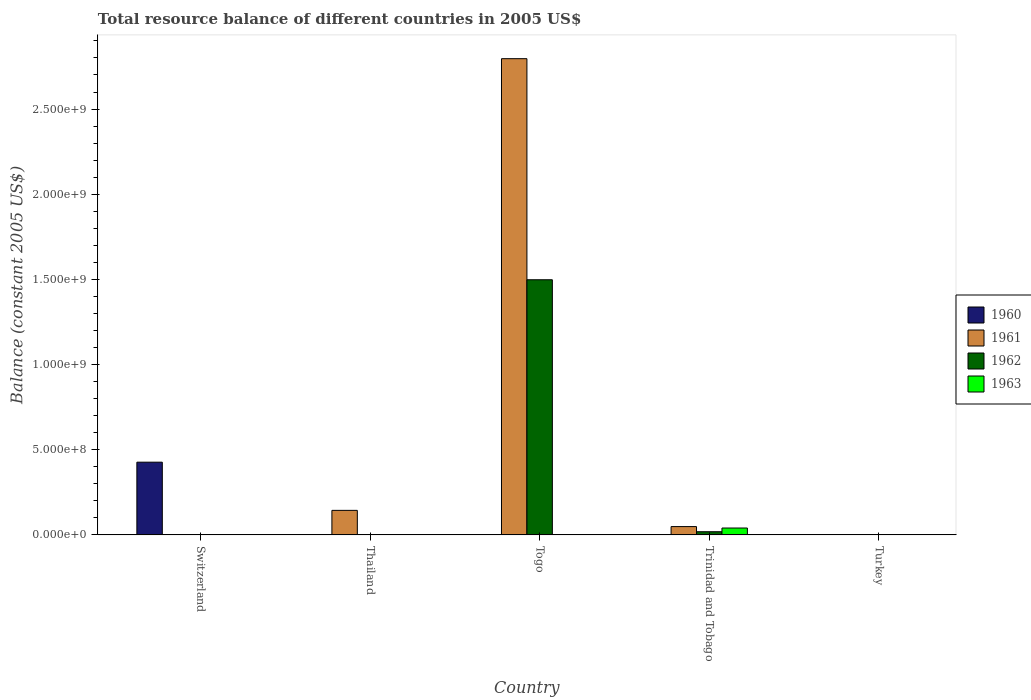Are the number of bars per tick equal to the number of legend labels?
Offer a very short reply. No. What is the label of the 3rd group of bars from the left?
Provide a succinct answer. Togo. What is the total resource balance in 1962 in Turkey?
Offer a terse response. 0. Across all countries, what is the maximum total resource balance in 1960?
Provide a short and direct response. 4.27e+08. Across all countries, what is the minimum total resource balance in 1960?
Make the answer very short. 0. In which country was the total resource balance in 1962 maximum?
Provide a succinct answer. Togo. What is the total total resource balance in 1962 in the graph?
Offer a very short reply. 1.52e+09. What is the difference between the total resource balance in 1961 in Thailand and that in Togo?
Offer a very short reply. -2.65e+09. What is the average total resource balance in 1961 per country?
Offer a very short reply. 5.98e+08. What is the difference between the total resource balance of/in 1962 and total resource balance of/in 1963 in Trinidad and Tobago?
Your answer should be compact. -2.17e+07. What is the ratio of the total resource balance in 1962 in Togo to that in Trinidad and Tobago?
Offer a terse response. 80.54. What is the difference between the highest and the second highest total resource balance in 1961?
Offer a terse response. 9.52e+07. What is the difference between the highest and the lowest total resource balance in 1962?
Offer a terse response. 1.50e+09. Is it the case that in every country, the sum of the total resource balance in 1962 and total resource balance in 1961 is greater than the sum of total resource balance in 1963 and total resource balance in 1960?
Ensure brevity in your answer.  No. Is it the case that in every country, the sum of the total resource balance in 1962 and total resource balance in 1961 is greater than the total resource balance in 1960?
Make the answer very short. No. How many bars are there?
Your answer should be compact. 7. Are all the bars in the graph horizontal?
Make the answer very short. No. How many countries are there in the graph?
Keep it short and to the point. 5. What is the difference between two consecutive major ticks on the Y-axis?
Offer a terse response. 5.00e+08. Does the graph contain any zero values?
Your response must be concise. Yes. Does the graph contain grids?
Offer a very short reply. No. Where does the legend appear in the graph?
Your answer should be compact. Center right. How many legend labels are there?
Keep it short and to the point. 4. What is the title of the graph?
Keep it short and to the point. Total resource balance of different countries in 2005 US$. Does "2011" appear as one of the legend labels in the graph?
Make the answer very short. No. What is the label or title of the Y-axis?
Ensure brevity in your answer.  Balance (constant 2005 US$). What is the Balance (constant 2005 US$) in 1960 in Switzerland?
Give a very brief answer. 4.27e+08. What is the Balance (constant 2005 US$) of 1962 in Switzerland?
Offer a very short reply. 0. What is the Balance (constant 2005 US$) in 1960 in Thailand?
Provide a succinct answer. 0. What is the Balance (constant 2005 US$) of 1961 in Thailand?
Provide a short and direct response. 1.44e+08. What is the Balance (constant 2005 US$) of 1960 in Togo?
Keep it short and to the point. 0. What is the Balance (constant 2005 US$) in 1961 in Togo?
Offer a terse response. 2.80e+09. What is the Balance (constant 2005 US$) in 1962 in Togo?
Offer a terse response. 1.50e+09. What is the Balance (constant 2005 US$) of 1960 in Trinidad and Tobago?
Provide a succinct answer. 0. What is the Balance (constant 2005 US$) in 1961 in Trinidad and Tobago?
Your answer should be very brief. 4.88e+07. What is the Balance (constant 2005 US$) of 1962 in Trinidad and Tobago?
Offer a terse response. 1.86e+07. What is the Balance (constant 2005 US$) in 1963 in Trinidad and Tobago?
Your response must be concise. 4.03e+07. What is the Balance (constant 2005 US$) in 1960 in Turkey?
Ensure brevity in your answer.  0. What is the Balance (constant 2005 US$) of 1961 in Turkey?
Your response must be concise. 0. What is the Balance (constant 2005 US$) of 1962 in Turkey?
Offer a very short reply. 0. Across all countries, what is the maximum Balance (constant 2005 US$) of 1960?
Provide a succinct answer. 4.27e+08. Across all countries, what is the maximum Balance (constant 2005 US$) of 1961?
Your response must be concise. 2.80e+09. Across all countries, what is the maximum Balance (constant 2005 US$) in 1962?
Your answer should be compact. 1.50e+09. Across all countries, what is the maximum Balance (constant 2005 US$) in 1963?
Make the answer very short. 4.03e+07. Across all countries, what is the minimum Balance (constant 2005 US$) in 1960?
Provide a succinct answer. 0. Across all countries, what is the minimum Balance (constant 2005 US$) in 1961?
Ensure brevity in your answer.  0. What is the total Balance (constant 2005 US$) of 1960 in the graph?
Your response must be concise. 4.27e+08. What is the total Balance (constant 2005 US$) of 1961 in the graph?
Give a very brief answer. 2.99e+09. What is the total Balance (constant 2005 US$) in 1962 in the graph?
Offer a terse response. 1.52e+09. What is the total Balance (constant 2005 US$) in 1963 in the graph?
Ensure brevity in your answer.  4.03e+07. What is the difference between the Balance (constant 2005 US$) in 1961 in Thailand and that in Togo?
Provide a short and direct response. -2.65e+09. What is the difference between the Balance (constant 2005 US$) of 1961 in Thailand and that in Trinidad and Tobago?
Make the answer very short. 9.52e+07. What is the difference between the Balance (constant 2005 US$) of 1961 in Togo and that in Trinidad and Tobago?
Provide a succinct answer. 2.75e+09. What is the difference between the Balance (constant 2005 US$) in 1962 in Togo and that in Trinidad and Tobago?
Your response must be concise. 1.48e+09. What is the difference between the Balance (constant 2005 US$) of 1960 in Switzerland and the Balance (constant 2005 US$) of 1961 in Thailand?
Provide a short and direct response. 2.83e+08. What is the difference between the Balance (constant 2005 US$) of 1960 in Switzerland and the Balance (constant 2005 US$) of 1961 in Togo?
Offer a terse response. -2.37e+09. What is the difference between the Balance (constant 2005 US$) of 1960 in Switzerland and the Balance (constant 2005 US$) of 1962 in Togo?
Your answer should be very brief. -1.07e+09. What is the difference between the Balance (constant 2005 US$) in 1960 in Switzerland and the Balance (constant 2005 US$) in 1961 in Trinidad and Tobago?
Keep it short and to the point. 3.78e+08. What is the difference between the Balance (constant 2005 US$) in 1960 in Switzerland and the Balance (constant 2005 US$) in 1962 in Trinidad and Tobago?
Give a very brief answer. 4.08e+08. What is the difference between the Balance (constant 2005 US$) of 1960 in Switzerland and the Balance (constant 2005 US$) of 1963 in Trinidad and Tobago?
Give a very brief answer. 3.87e+08. What is the difference between the Balance (constant 2005 US$) of 1961 in Thailand and the Balance (constant 2005 US$) of 1962 in Togo?
Your response must be concise. -1.35e+09. What is the difference between the Balance (constant 2005 US$) in 1961 in Thailand and the Balance (constant 2005 US$) in 1962 in Trinidad and Tobago?
Offer a terse response. 1.25e+08. What is the difference between the Balance (constant 2005 US$) of 1961 in Thailand and the Balance (constant 2005 US$) of 1963 in Trinidad and Tobago?
Your answer should be compact. 1.04e+08. What is the difference between the Balance (constant 2005 US$) of 1961 in Togo and the Balance (constant 2005 US$) of 1962 in Trinidad and Tobago?
Your response must be concise. 2.78e+09. What is the difference between the Balance (constant 2005 US$) of 1961 in Togo and the Balance (constant 2005 US$) of 1963 in Trinidad and Tobago?
Provide a short and direct response. 2.76e+09. What is the difference between the Balance (constant 2005 US$) of 1962 in Togo and the Balance (constant 2005 US$) of 1963 in Trinidad and Tobago?
Make the answer very short. 1.46e+09. What is the average Balance (constant 2005 US$) of 1960 per country?
Your answer should be very brief. 8.54e+07. What is the average Balance (constant 2005 US$) in 1961 per country?
Offer a very short reply. 5.98e+08. What is the average Balance (constant 2005 US$) of 1962 per country?
Give a very brief answer. 3.03e+08. What is the average Balance (constant 2005 US$) of 1963 per country?
Make the answer very short. 8.06e+06. What is the difference between the Balance (constant 2005 US$) in 1961 and Balance (constant 2005 US$) in 1962 in Togo?
Your answer should be very brief. 1.30e+09. What is the difference between the Balance (constant 2005 US$) of 1961 and Balance (constant 2005 US$) of 1962 in Trinidad and Tobago?
Your answer should be compact. 3.02e+07. What is the difference between the Balance (constant 2005 US$) of 1961 and Balance (constant 2005 US$) of 1963 in Trinidad and Tobago?
Offer a terse response. 8.50e+06. What is the difference between the Balance (constant 2005 US$) of 1962 and Balance (constant 2005 US$) of 1963 in Trinidad and Tobago?
Your answer should be compact. -2.17e+07. What is the ratio of the Balance (constant 2005 US$) of 1961 in Thailand to that in Togo?
Make the answer very short. 0.05. What is the ratio of the Balance (constant 2005 US$) in 1961 in Thailand to that in Trinidad and Tobago?
Give a very brief answer. 2.95. What is the ratio of the Balance (constant 2005 US$) in 1961 in Togo to that in Trinidad and Tobago?
Keep it short and to the point. 57.29. What is the ratio of the Balance (constant 2005 US$) in 1962 in Togo to that in Trinidad and Tobago?
Your response must be concise. 80.54. What is the difference between the highest and the second highest Balance (constant 2005 US$) in 1961?
Keep it short and to the point. 2.65e+09. What is the difference between the highest and the lowest Balance (constant 2005 US$) in 1960?
Your response must be concise. 4.27e+08. What is the difference between the highest and the lowest Balance (constant 2005 US$) in 1961?
Keep it short and to the point. 2.80e+09. What is the difference between the highest and the lowest Balance (constant 2005 US$) in 1962?
Make the answer very short. 1.50e+09. What is the difference between the highest and the lowest Balance (constant 2005 US$) of 1963?
Make the answer very short. 4.03e+07. 